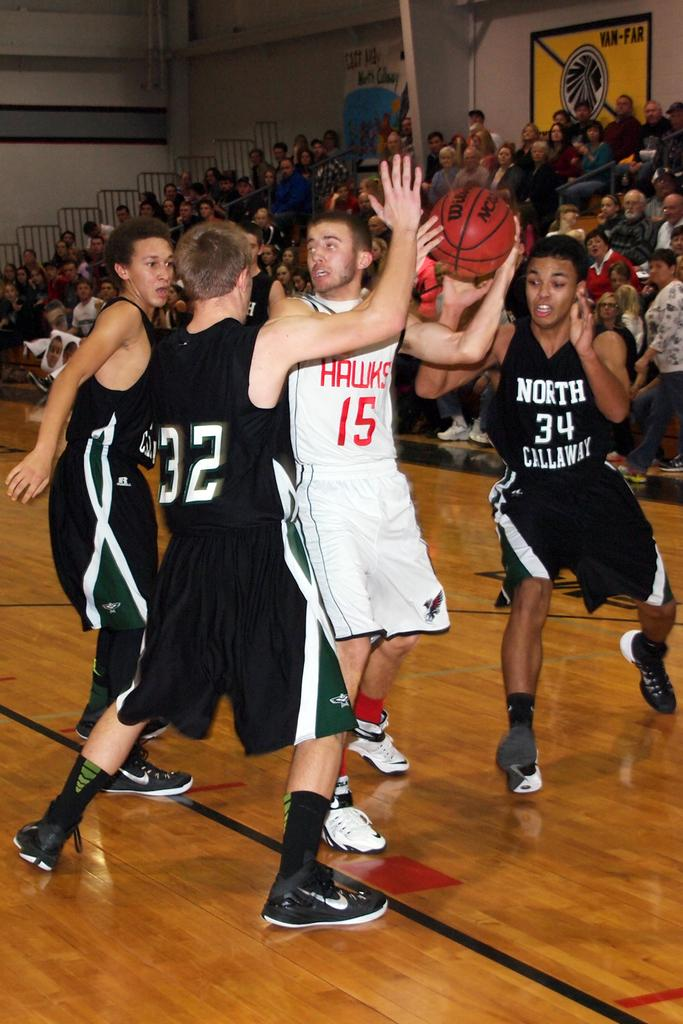<image>
Share a concise interpretation of the image provided. Basketball players on the court Hawks 15 has the ball 